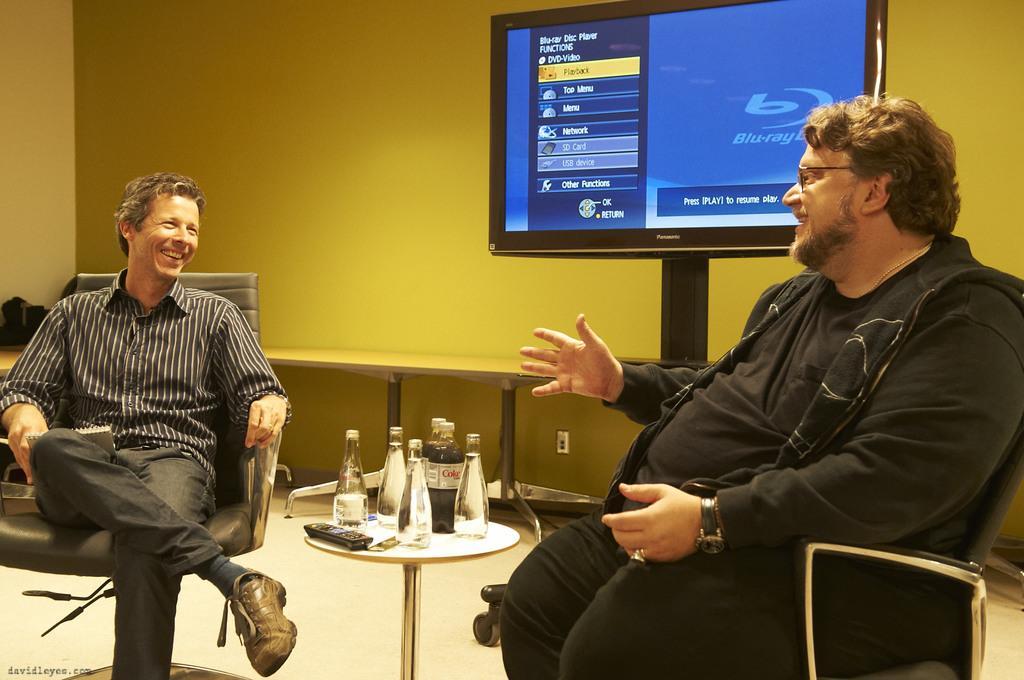Could you give a brief overview of what you see in this image? In this image, two people are sitting on a chair and smiling. In the middle of the image, we can see a table, few items are placed on it. Background we can see a desk, wall, television. Left side of the image, we can see some black color objects. At the bottom of the image, we can see a watermark. 